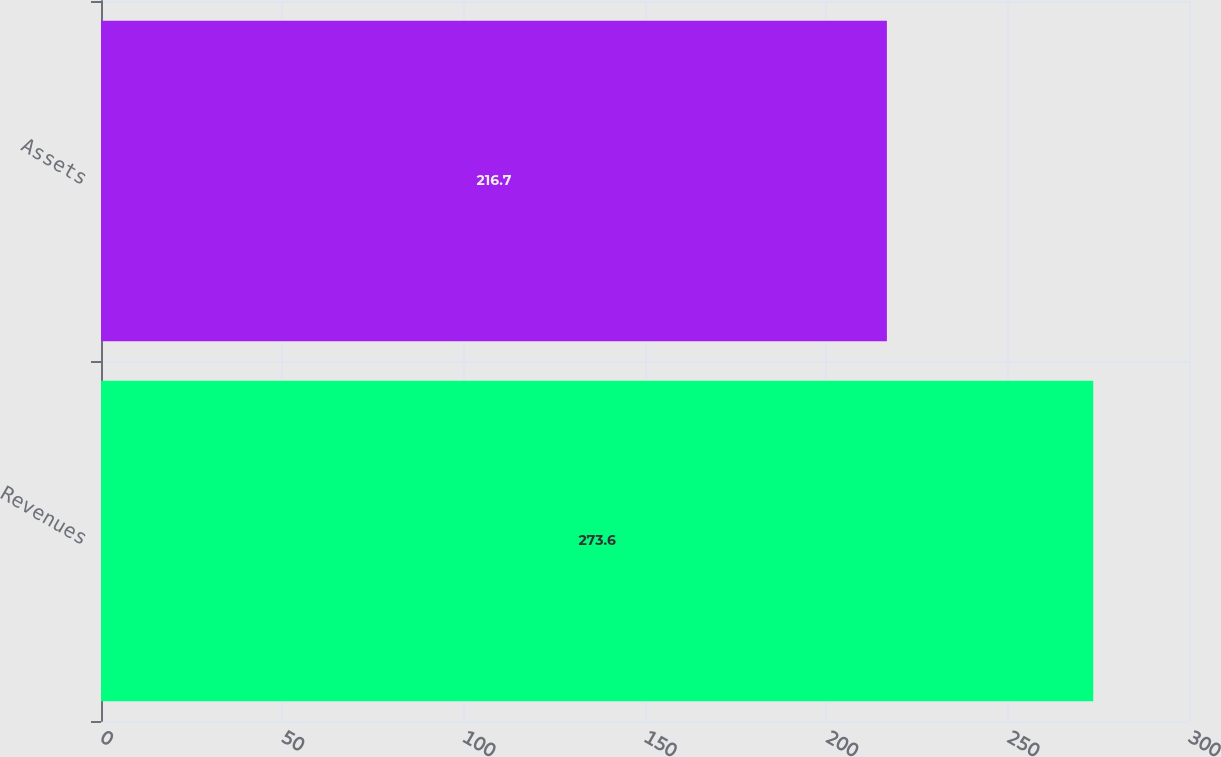<chart> <loc_0><loc_0><loc_500><loc_500><bar_chart><fcel>Revenues<fcel>Assets<nl><fcel>273.6<fcel>216.7<nl></chart> 